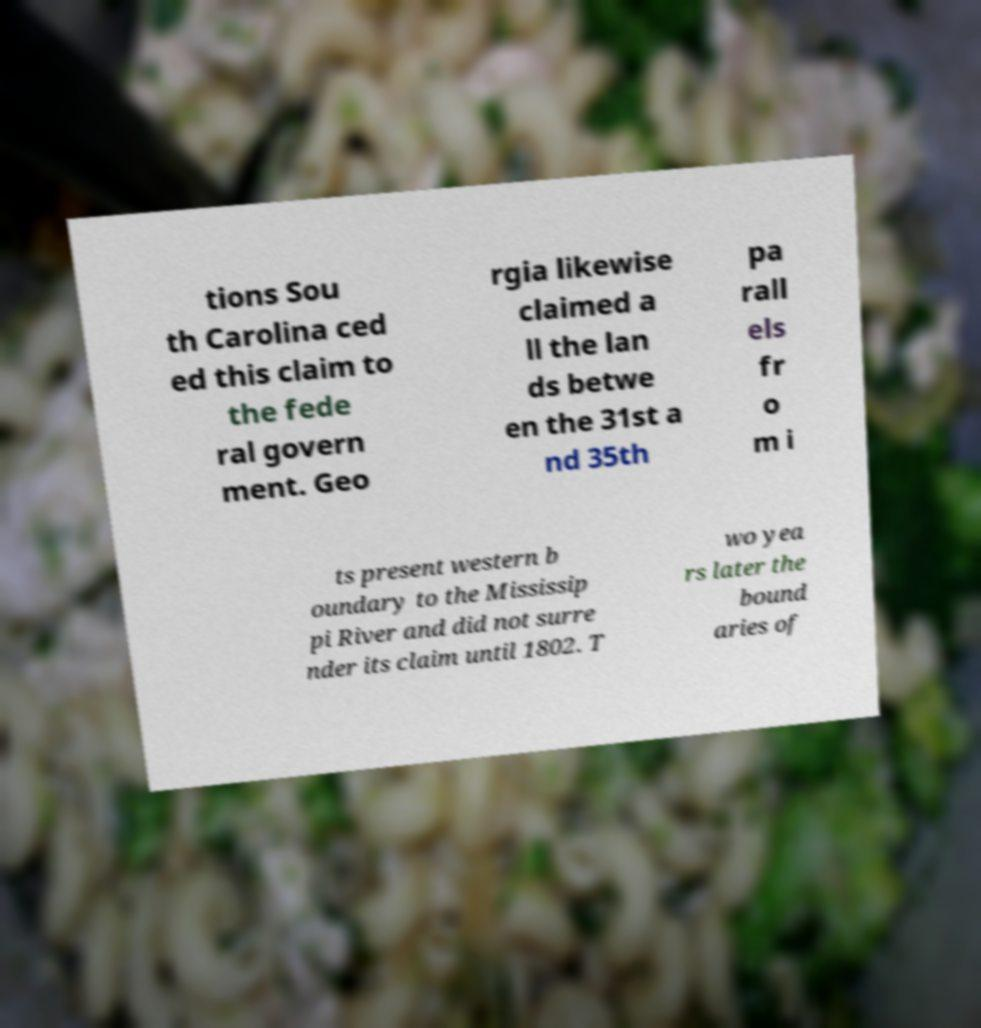What messages or text are displayed in this image? I need them in a readable, typed format. tions Sou th Carolina ced ed this claim to the fede ral govern ment. Geo rgia likewise claimed a ll the lan ds betwe en the 31st a nd 35th pa rall els fr o m i ts present western b oundary to the Mississip pi River and did not surre nder its claim until 1802. T wo yea rs later the bound aries of 